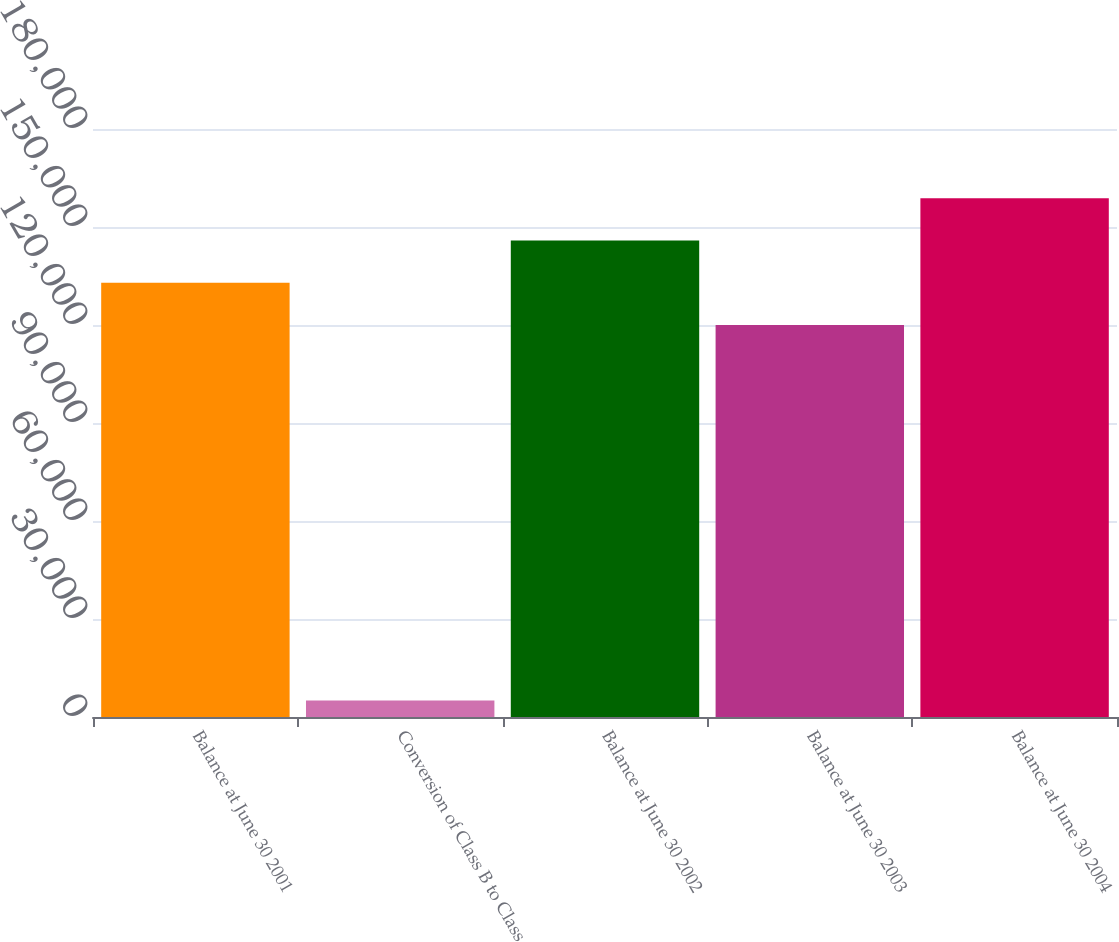Convert chart to OTSL. <chart><loc_0><loc_0><loc_500><loc_500><bar_chart><fcel>Balance at June 30 2001<fcel>Conversion of Class B to Class<fcel>Balance at June 30 2002<fcel>Balance at June 30 2003<fcel>Balance at June 30 2004<nl><fcel>132937<fcel>5077.8<fcel>145881<fcel>119994<fcel>158825<nl></chart> 